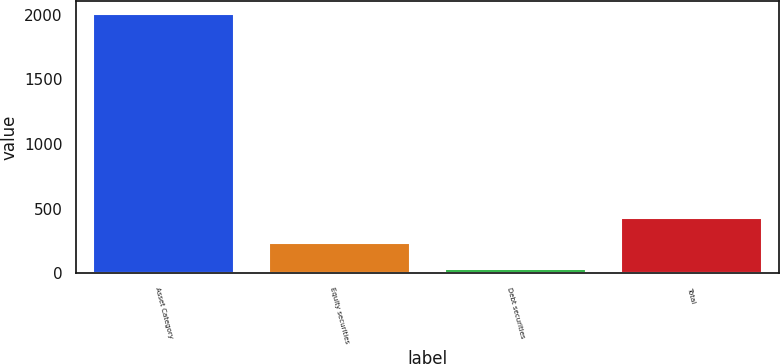Convert chart to OTSL. <chart><loc_0><loc_0><loc_500><loc_500><bar_chart><fcel>Asset Category<fcel>Equity securities<fcel>Debt securities<fcel>Total<nl><fcel>2007<fcel>233.1<fcel>36<fcel>430.2<nl></chart> 